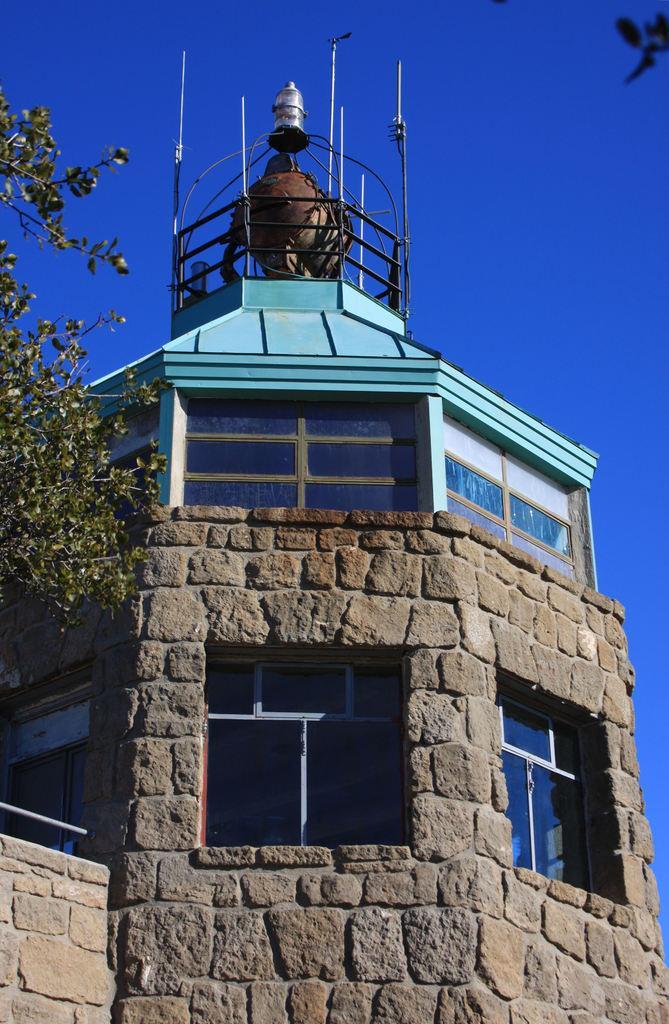Could you give a brief overview of what you see in this image? In the image there is a building in the front with tree on the left side and a antenna above it and above its sky. 